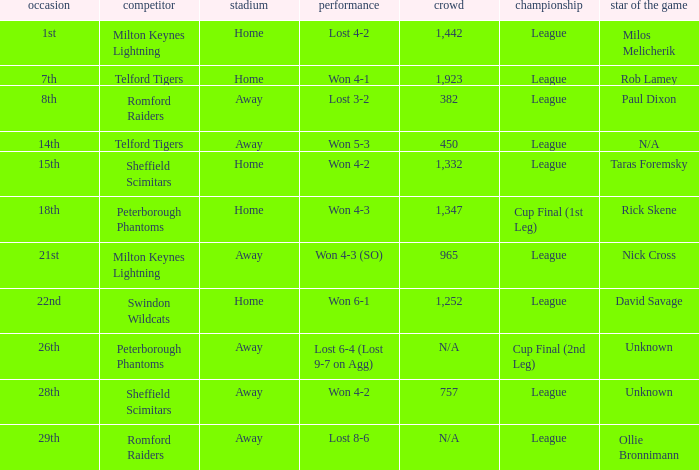What was the result on the 26th? Lost 6-4 (Lost 9-7 on Agg). 